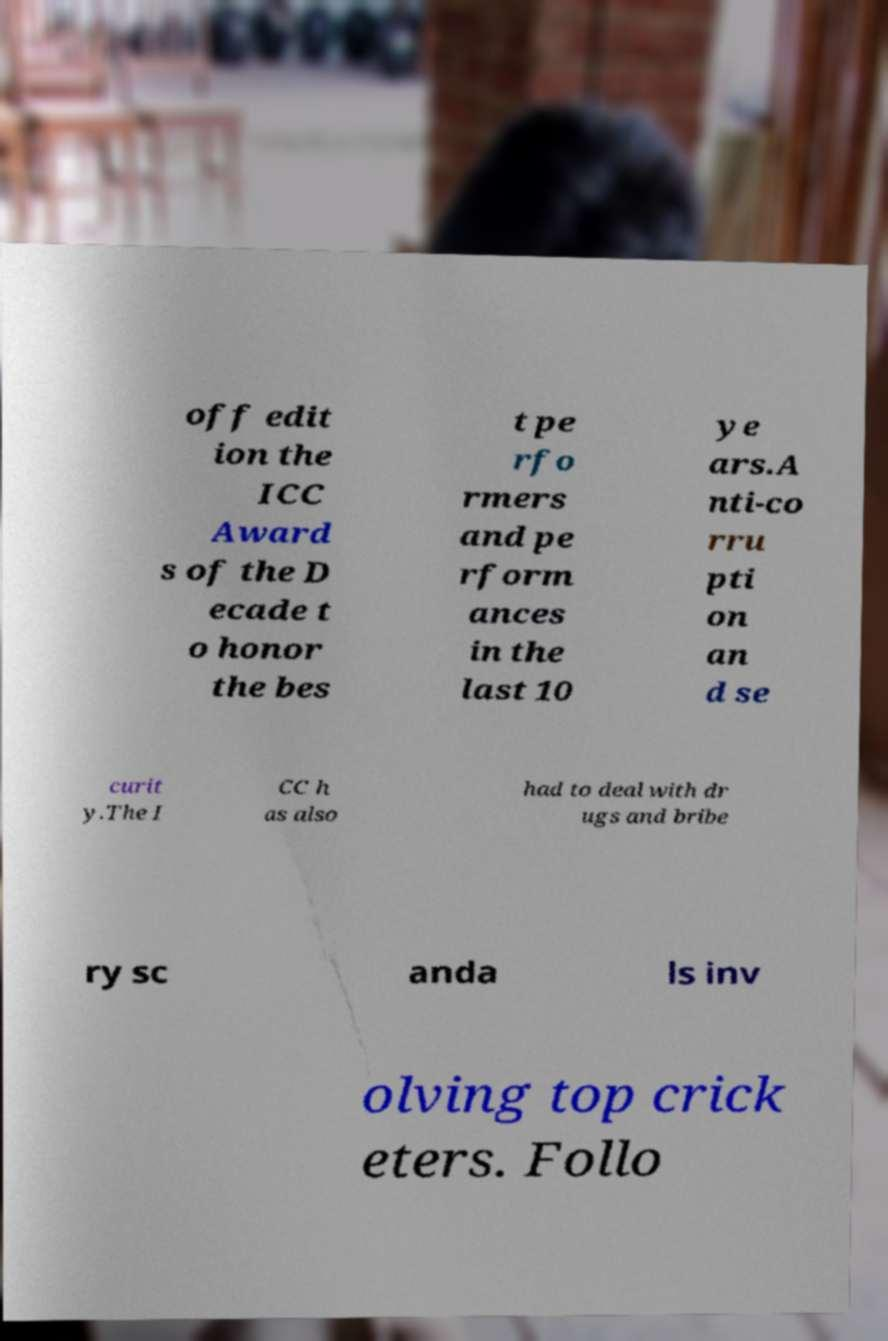Can you read and provide the text displayed in the image?This photo seems to have some interesting text. Can you extract and type it out for me? off edit ion the ICC Award s of the D ecade t o honor the bes t pe rfo rmers and pe rform ances in the last 10 ye ars.A nti-co rru pti on an d se curit y.The I CC h as also had to deal with dr ugs and bribe ry sc anda ls inv olving top crick eters. Follo 